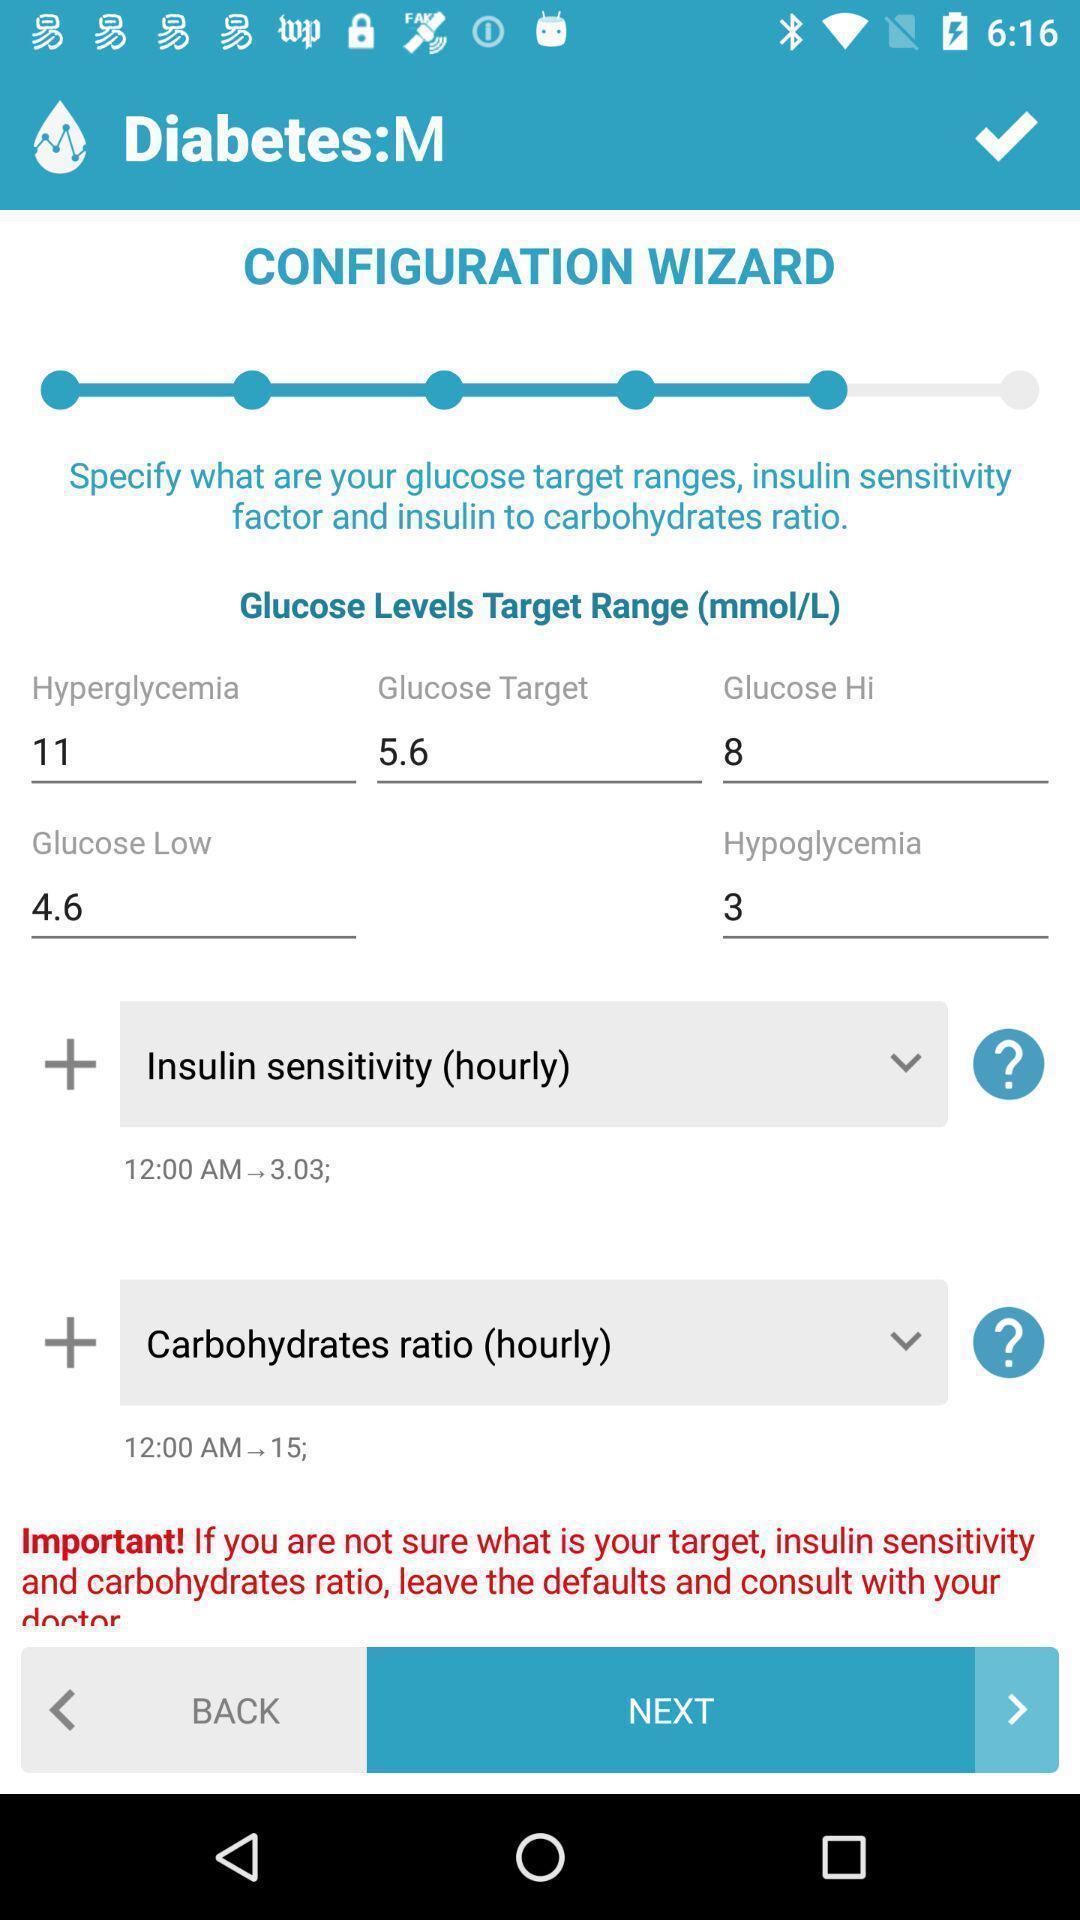Explain the elements present in this screenshot. Screen page of a diabetes management app. 